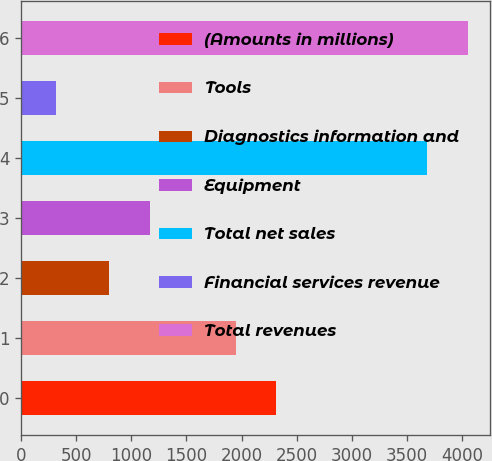<chart> <loc_0><loc_0><loc_500><loc_500><bar_chart><fcel>(Amounts in millions)<fcel>Tools<fcel>Diagnostics information and<fcel>Equipment<fcel>Total net sales<fcel>Financial services revenue<fcel>Total revenues<nl><fcel>2315.39<fcel>1946.7<fcel>800.4<fcel>1169.09<fcel>3686.9<fcel>313.4<fcel>4055.59<nl></chart> 